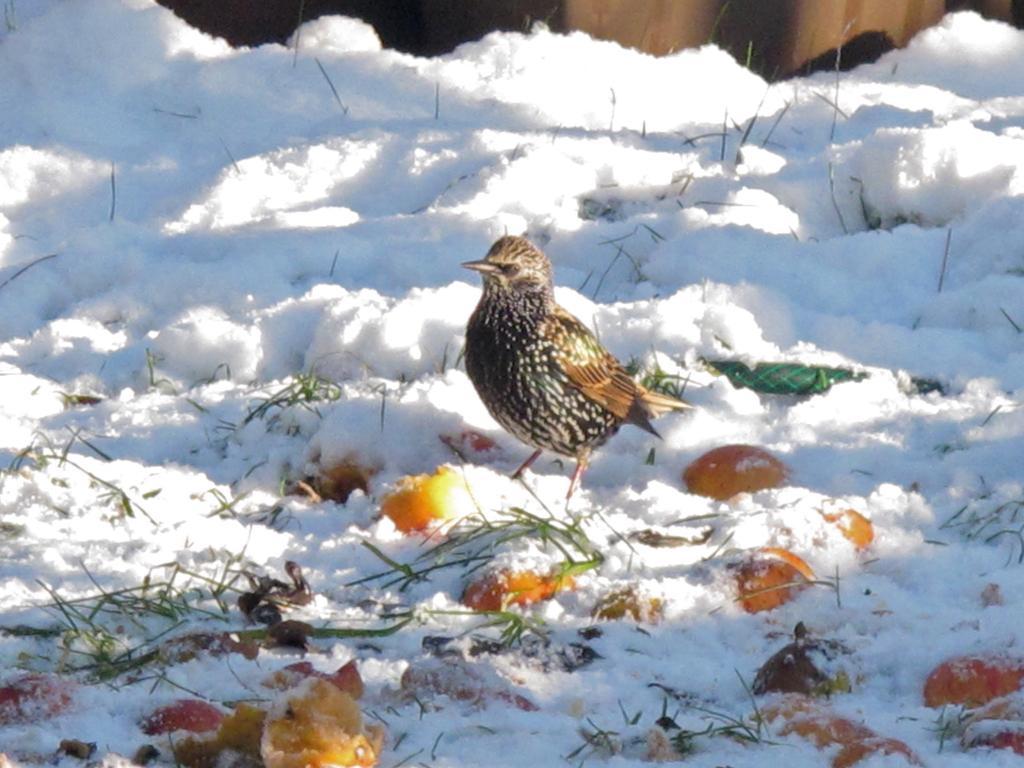In one or two sentences, can you explain what this image depicts? In this image we can see fruits and bird standing on the ground covered with snow. 